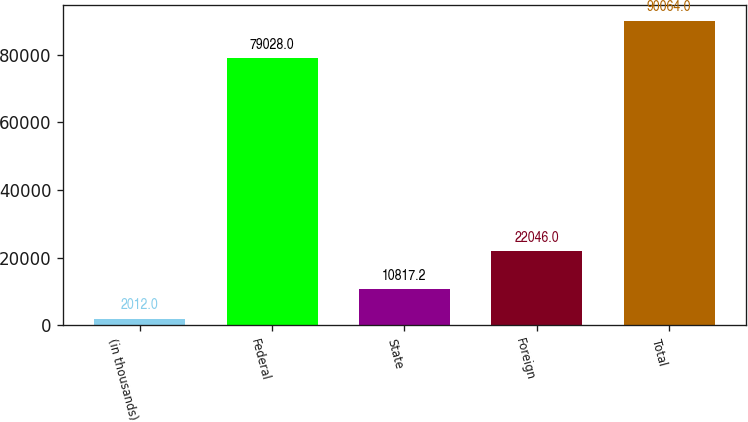Convert chart to OTSL. <chart><loc_0><loc_0><loc_500><loc_500><bar_chart><fcel>(in thousands)<fcel>Federal<fcel>State<fcel>Foreign<fcel>Total<nl><fcel>2012<fcel>79028<fcel>10817.2<fcel>22046<fcel>90064<nl></chart> 